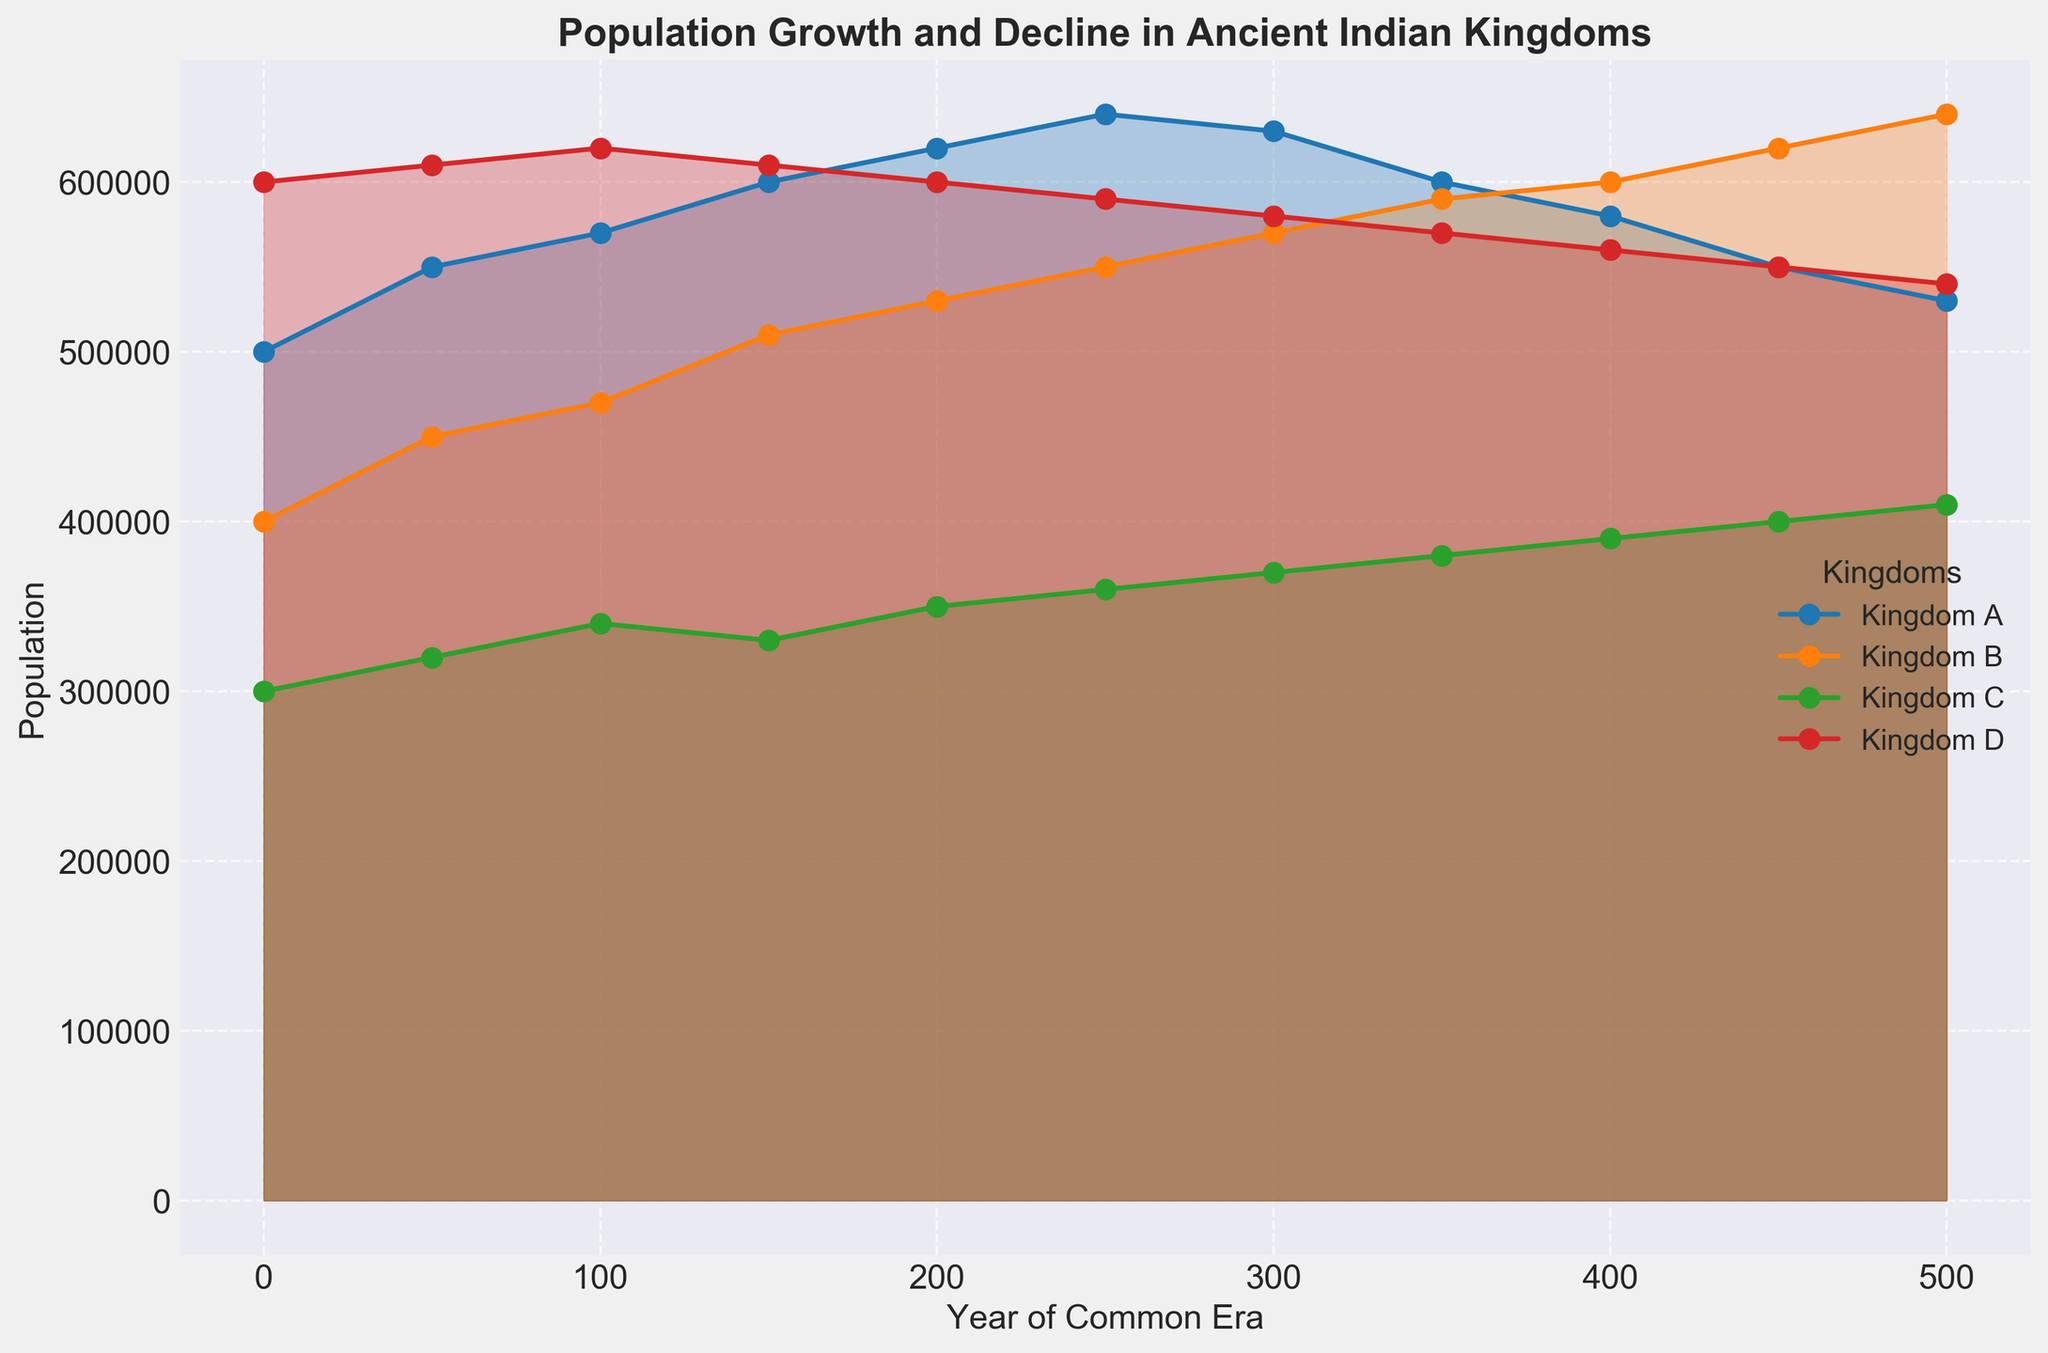What is the population trend of Kingdom A over the Common Era? The population of Kingdom A initially rises from 500,000 in year 0 to 640,000 by year 250. Afterward, it shows a decline, decreasing to 530,000 by year 500.
Answer: Initial increase, then decline Which kingdom had the highest population at year 0 and year 500? At year 0, Kingdom D had the highest population with 600,000 people. By year 500, Kingdom B had the highest population with 640,000 people.
Answer: Kingdom D at year 0, Kingdom B at year 500 During which period did Kingdom B experience the most significant population growth? Kingdom B experienced significant population growth between 200 and 250, with an increase from 530,000 to 550,000, which is a growth of 20,000.
Answer: 200 to 250 Compare the population trends of Kingdom C and Kingdom D from year 0 to year 500. Kingdom C shows a continuous increase in population from 300,000 to 410,000. Kingdom D, on the other hand, displays a consistent decline from 600,000 to 540,000.
Answer: Continuous increase for Kingdom C, continuous decline for Kingdom D What is the overall population difference of Kingdom A from year 0 to year 500? The population of Kingdom A starts at 500,000 and ends at 530,000 at year 500. The difference is 530,000 - 500,000 = 30,000.
Answer: 30,000 Which two kingdoms have the most contrasting trends from year 300 to year 500? Kingdom A saw a decline from 630,000 to 530,000, while Kingdom B saw an increase from 570,000 to 640,000. The contrasting trends are a decline and an increase.
Answer: Kingdom A and Kingdom B What is the average population of Kingdom C over the Common Era? The population values for Kingdom C over the Common Era are {300,000; 320,000; 340,000; 330,000; 350,000; 360,000; 370,000; 380,000; 390,000; 400,000; 410,000}. The average is (sum of all values)/11 = 3,870,000/11 = 351,818.
Answer: 351,818 